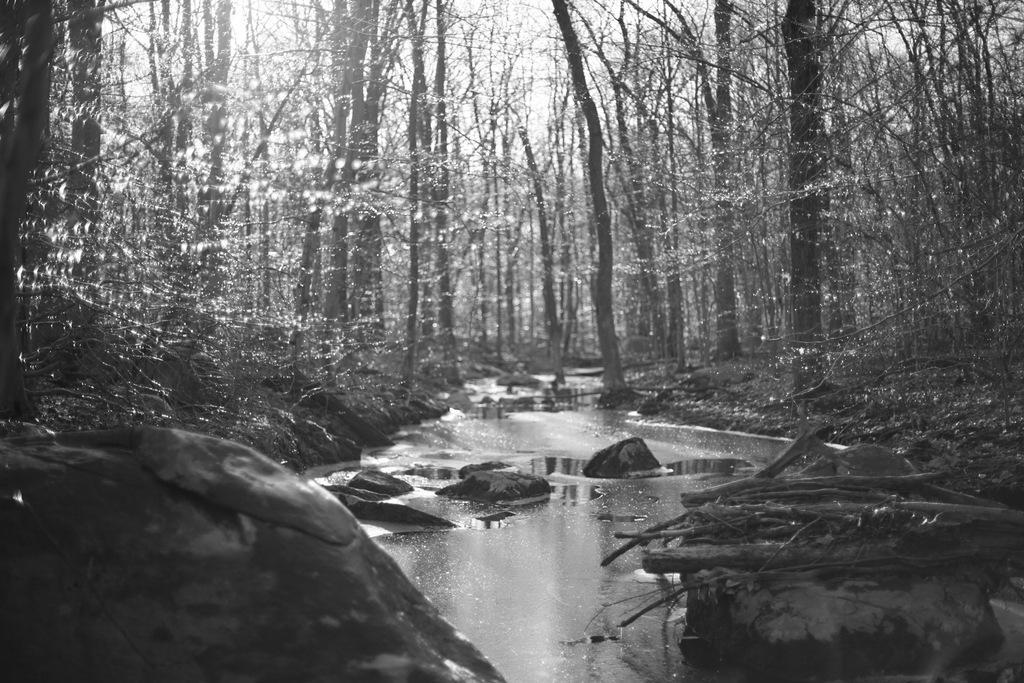Can you describe this image briefly? This is a black and white picture. In this picture we can see the trees and the sky is visible. We can see the water, rocks and the branches. 